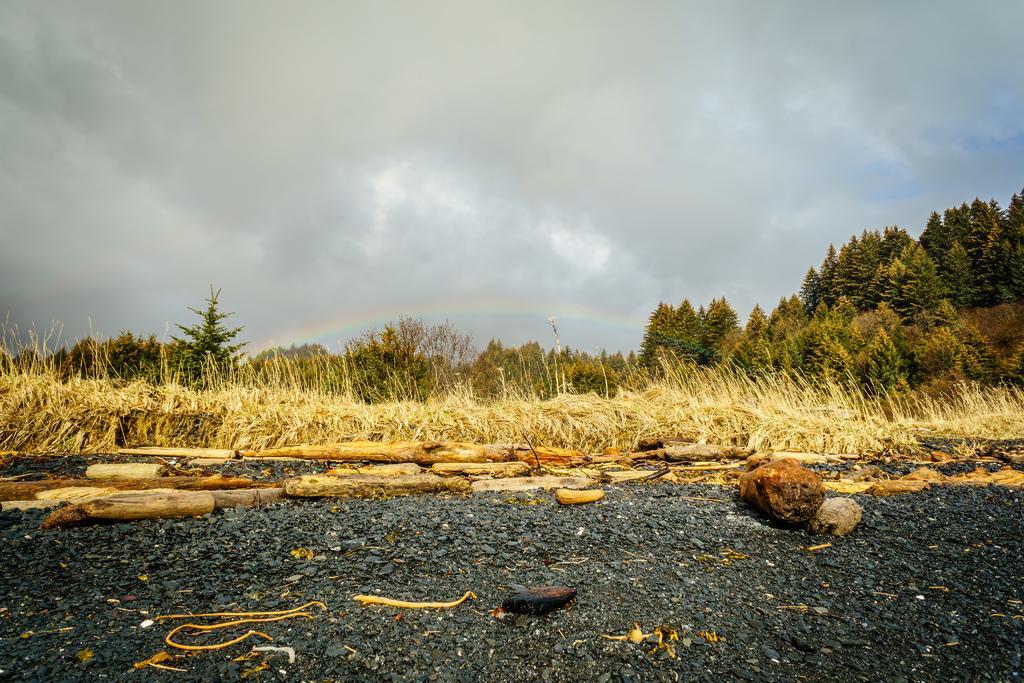Could you give a brief overview of what you see in this image? In this image I can see few stones. Background I can see dried grass, trees in green color and sky in blue and white color. 